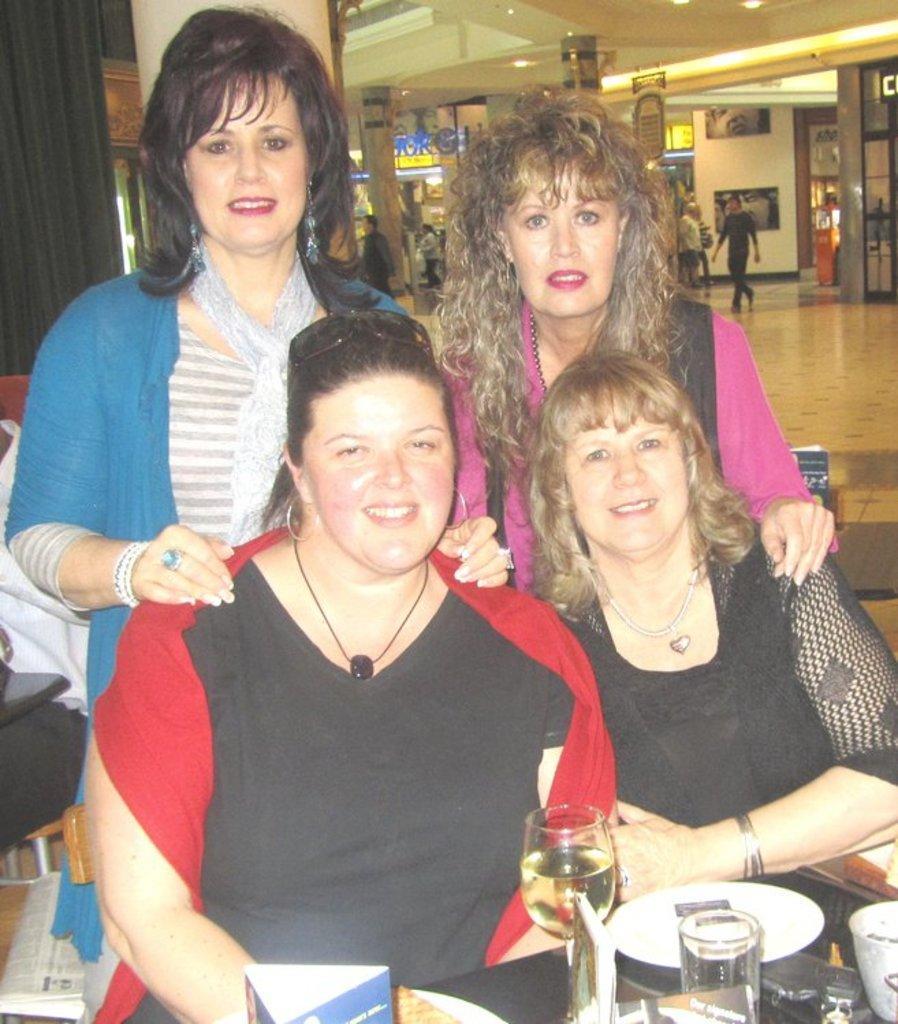Can you describe this image briefly? There are two women sitting on chairs,. behind these women there are two women standing. We can see plates, glasses and objects on the table. In the background we can see cloth, paper, pillars, curtain, people, floorboards, wall and lights. 